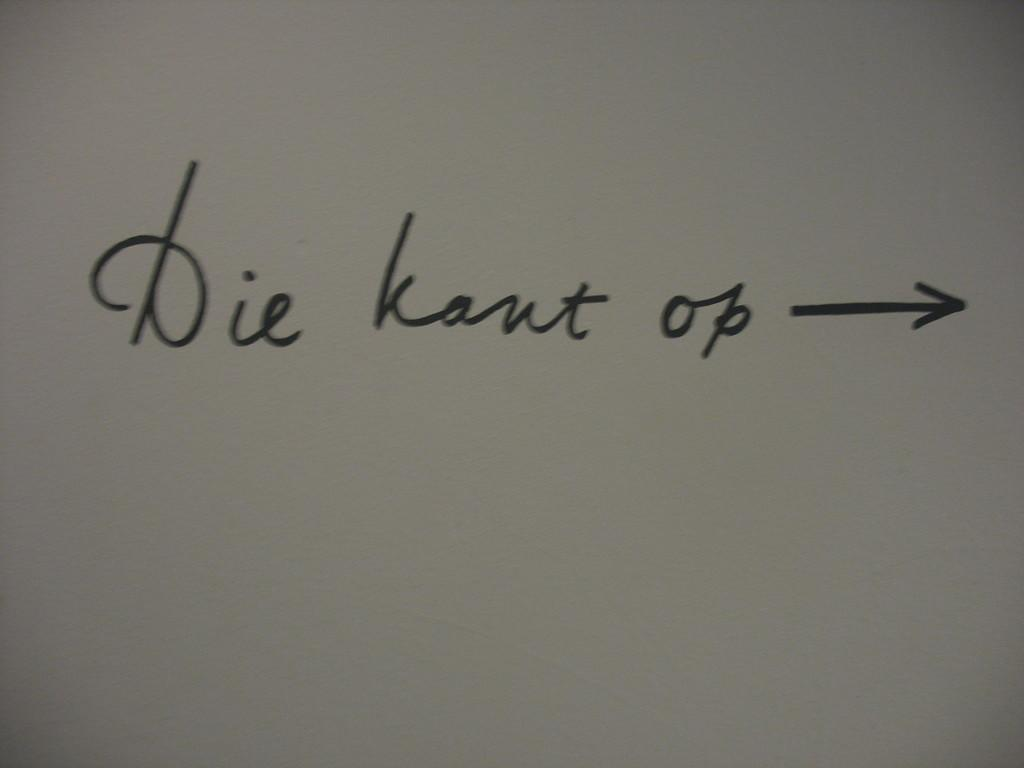<image>
Create a compact narrative representing the image presented. Someone has written die kant op with an arrow on a white page. 